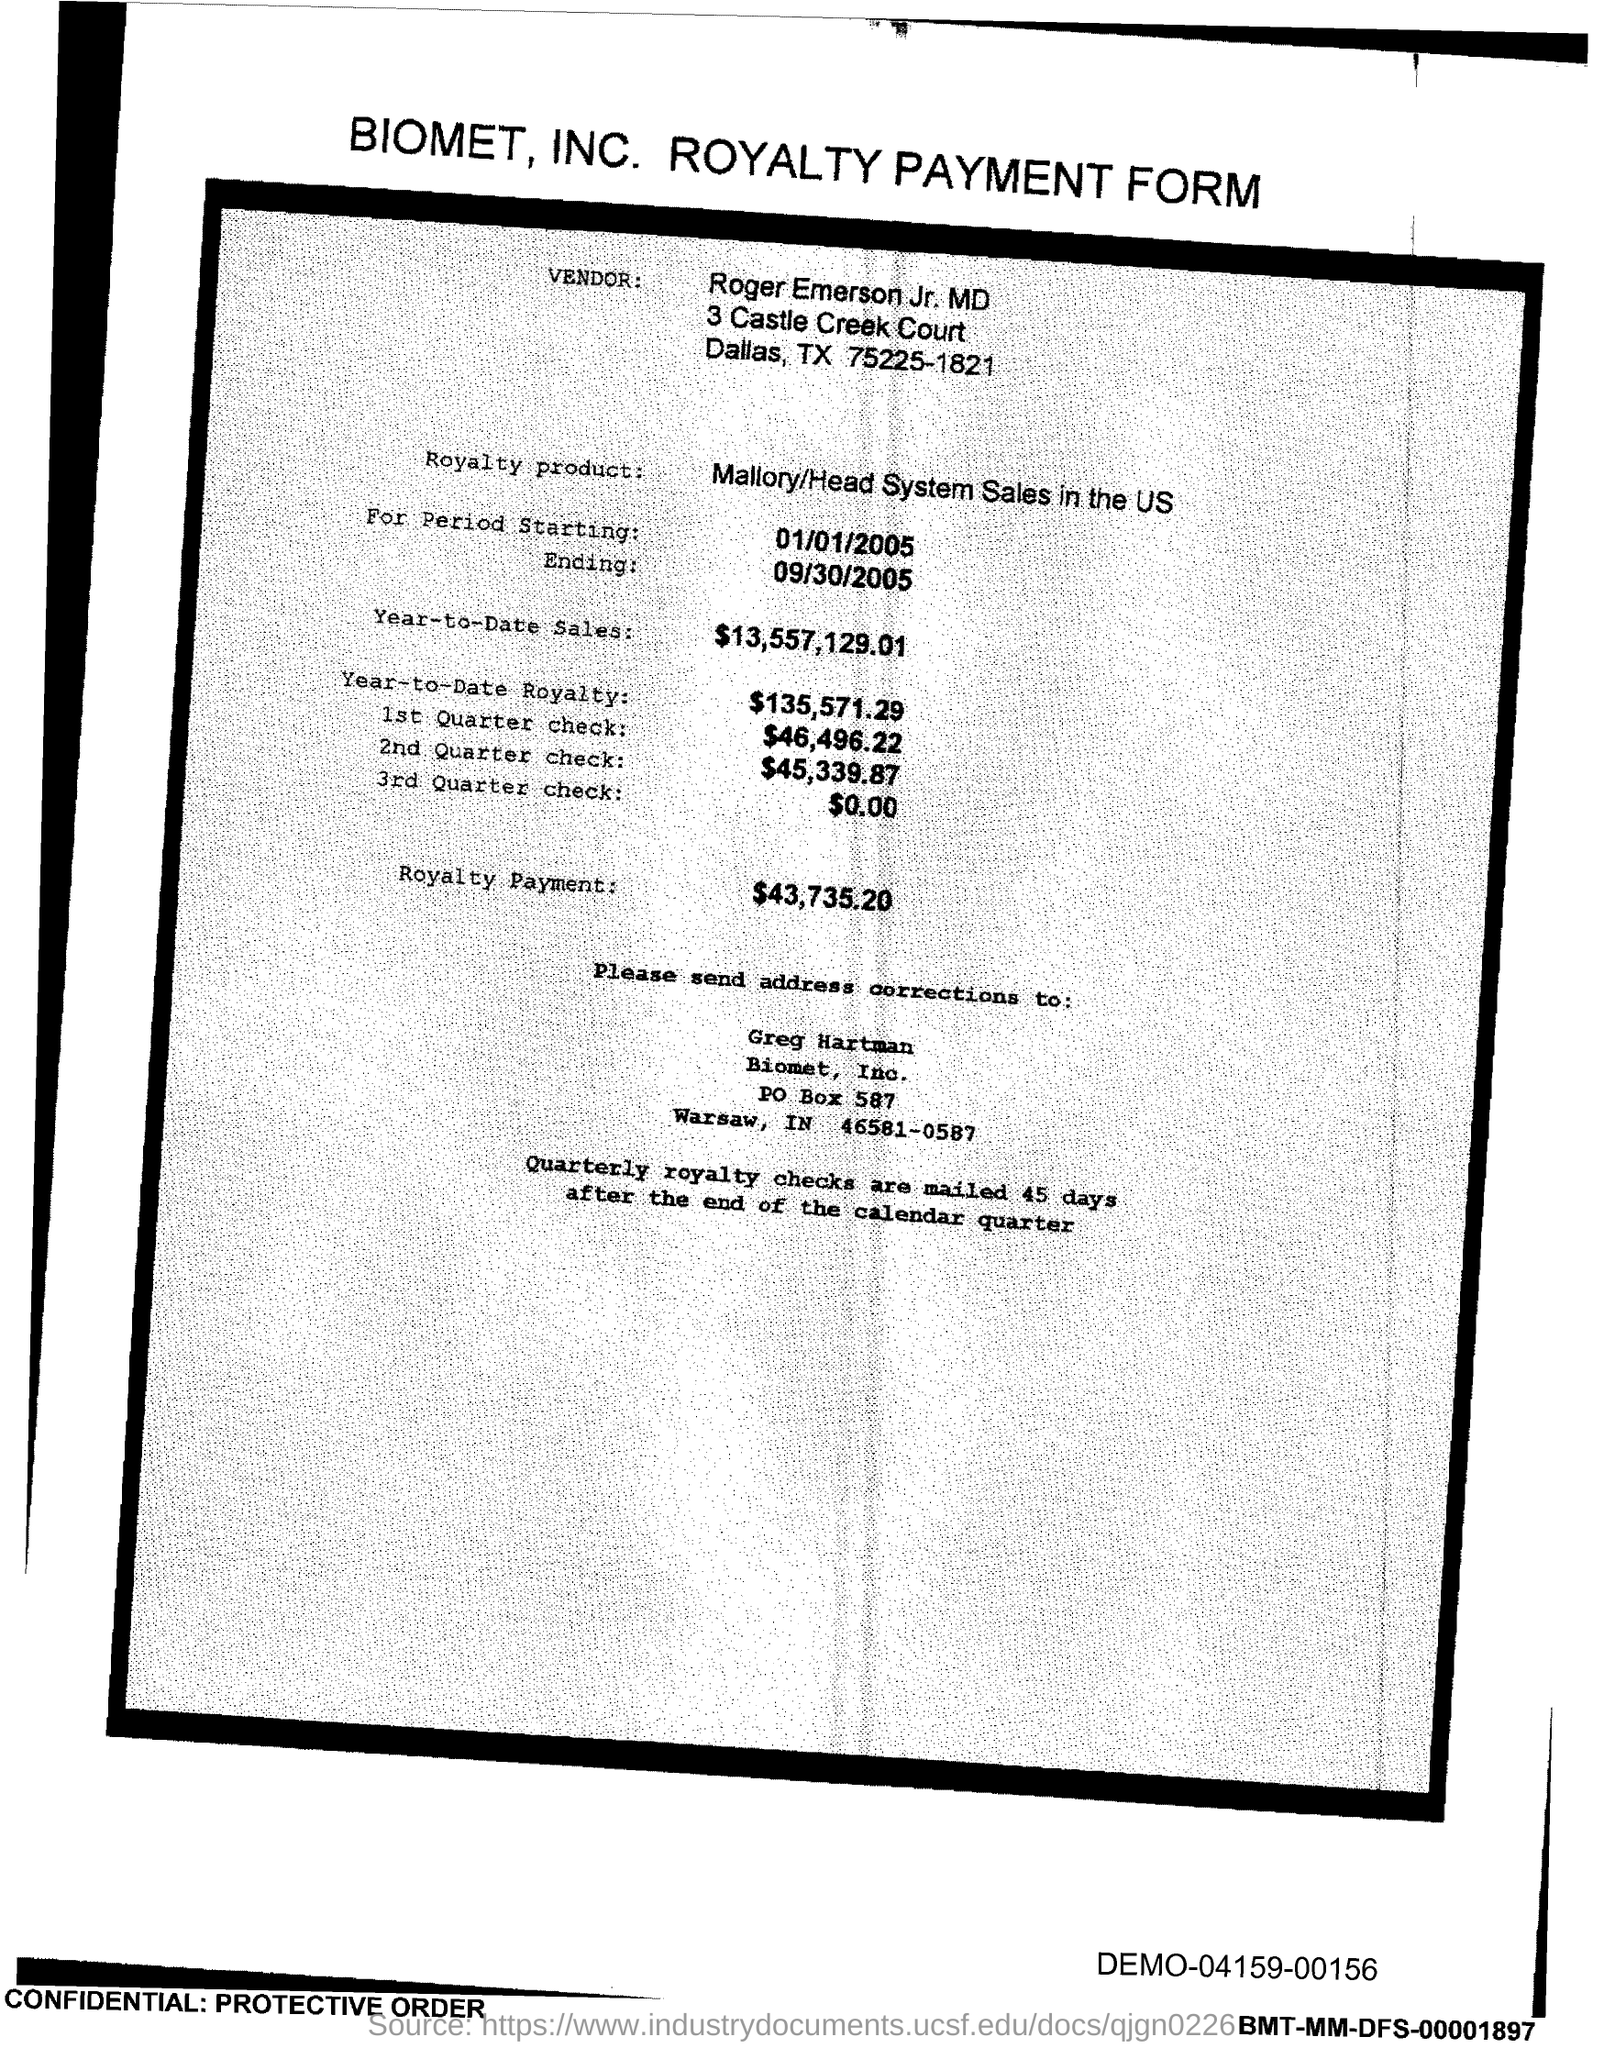What is the PO Box Number mentioned in the document?
Your answer should be very brief. 587. 